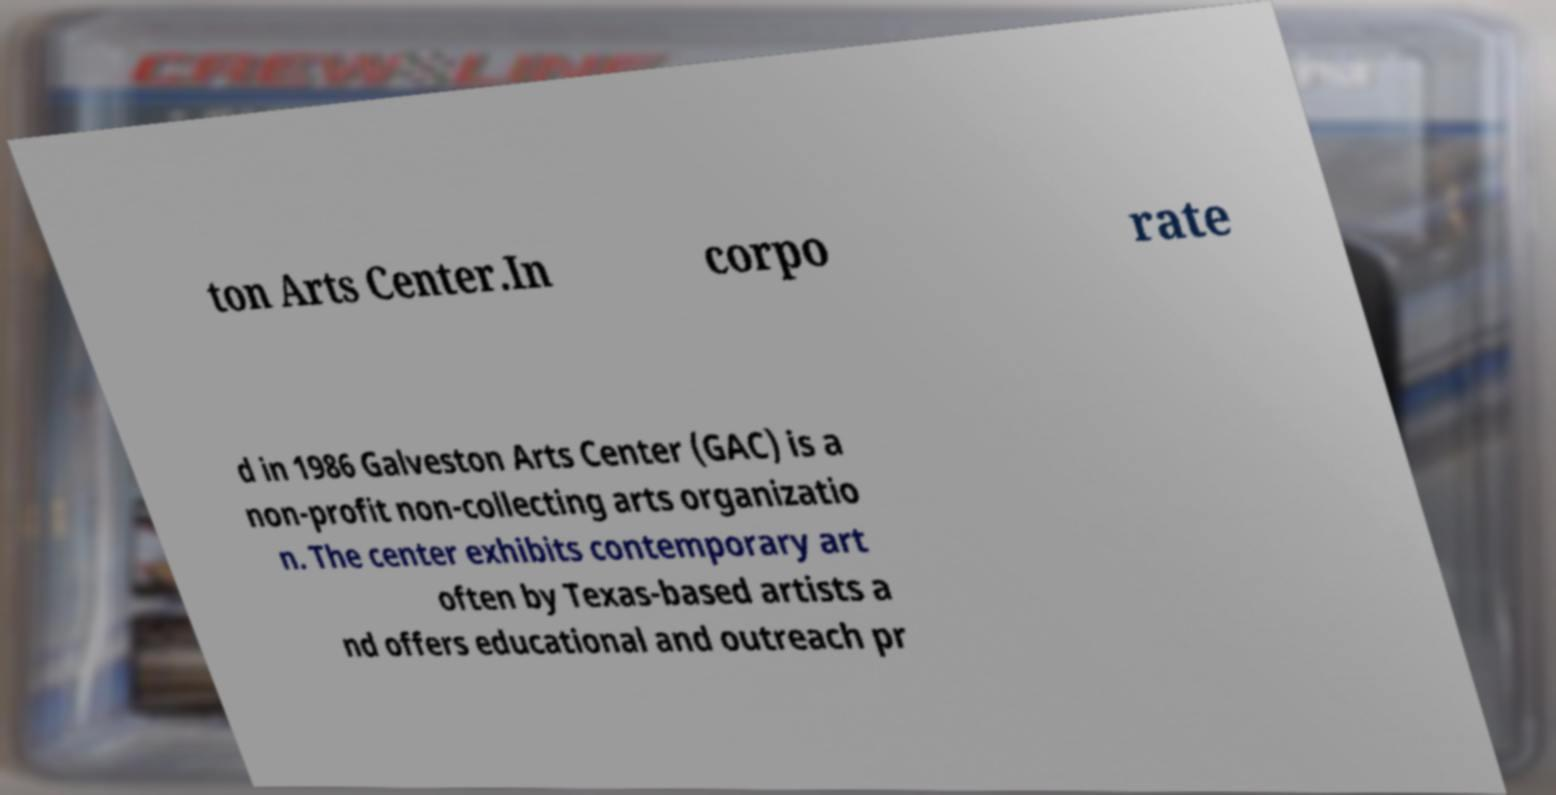There's text embedded in this image that I need extracted. Can you transcribe it verbatim? ton Arts Center.In corpo rate d in 1986 Galveston Arts Center (GAC) is a non-profit non-collecting arts organizatio n. The center exhibits contemporary art often by Texas-based artists a nd offers educational and outreach pr 